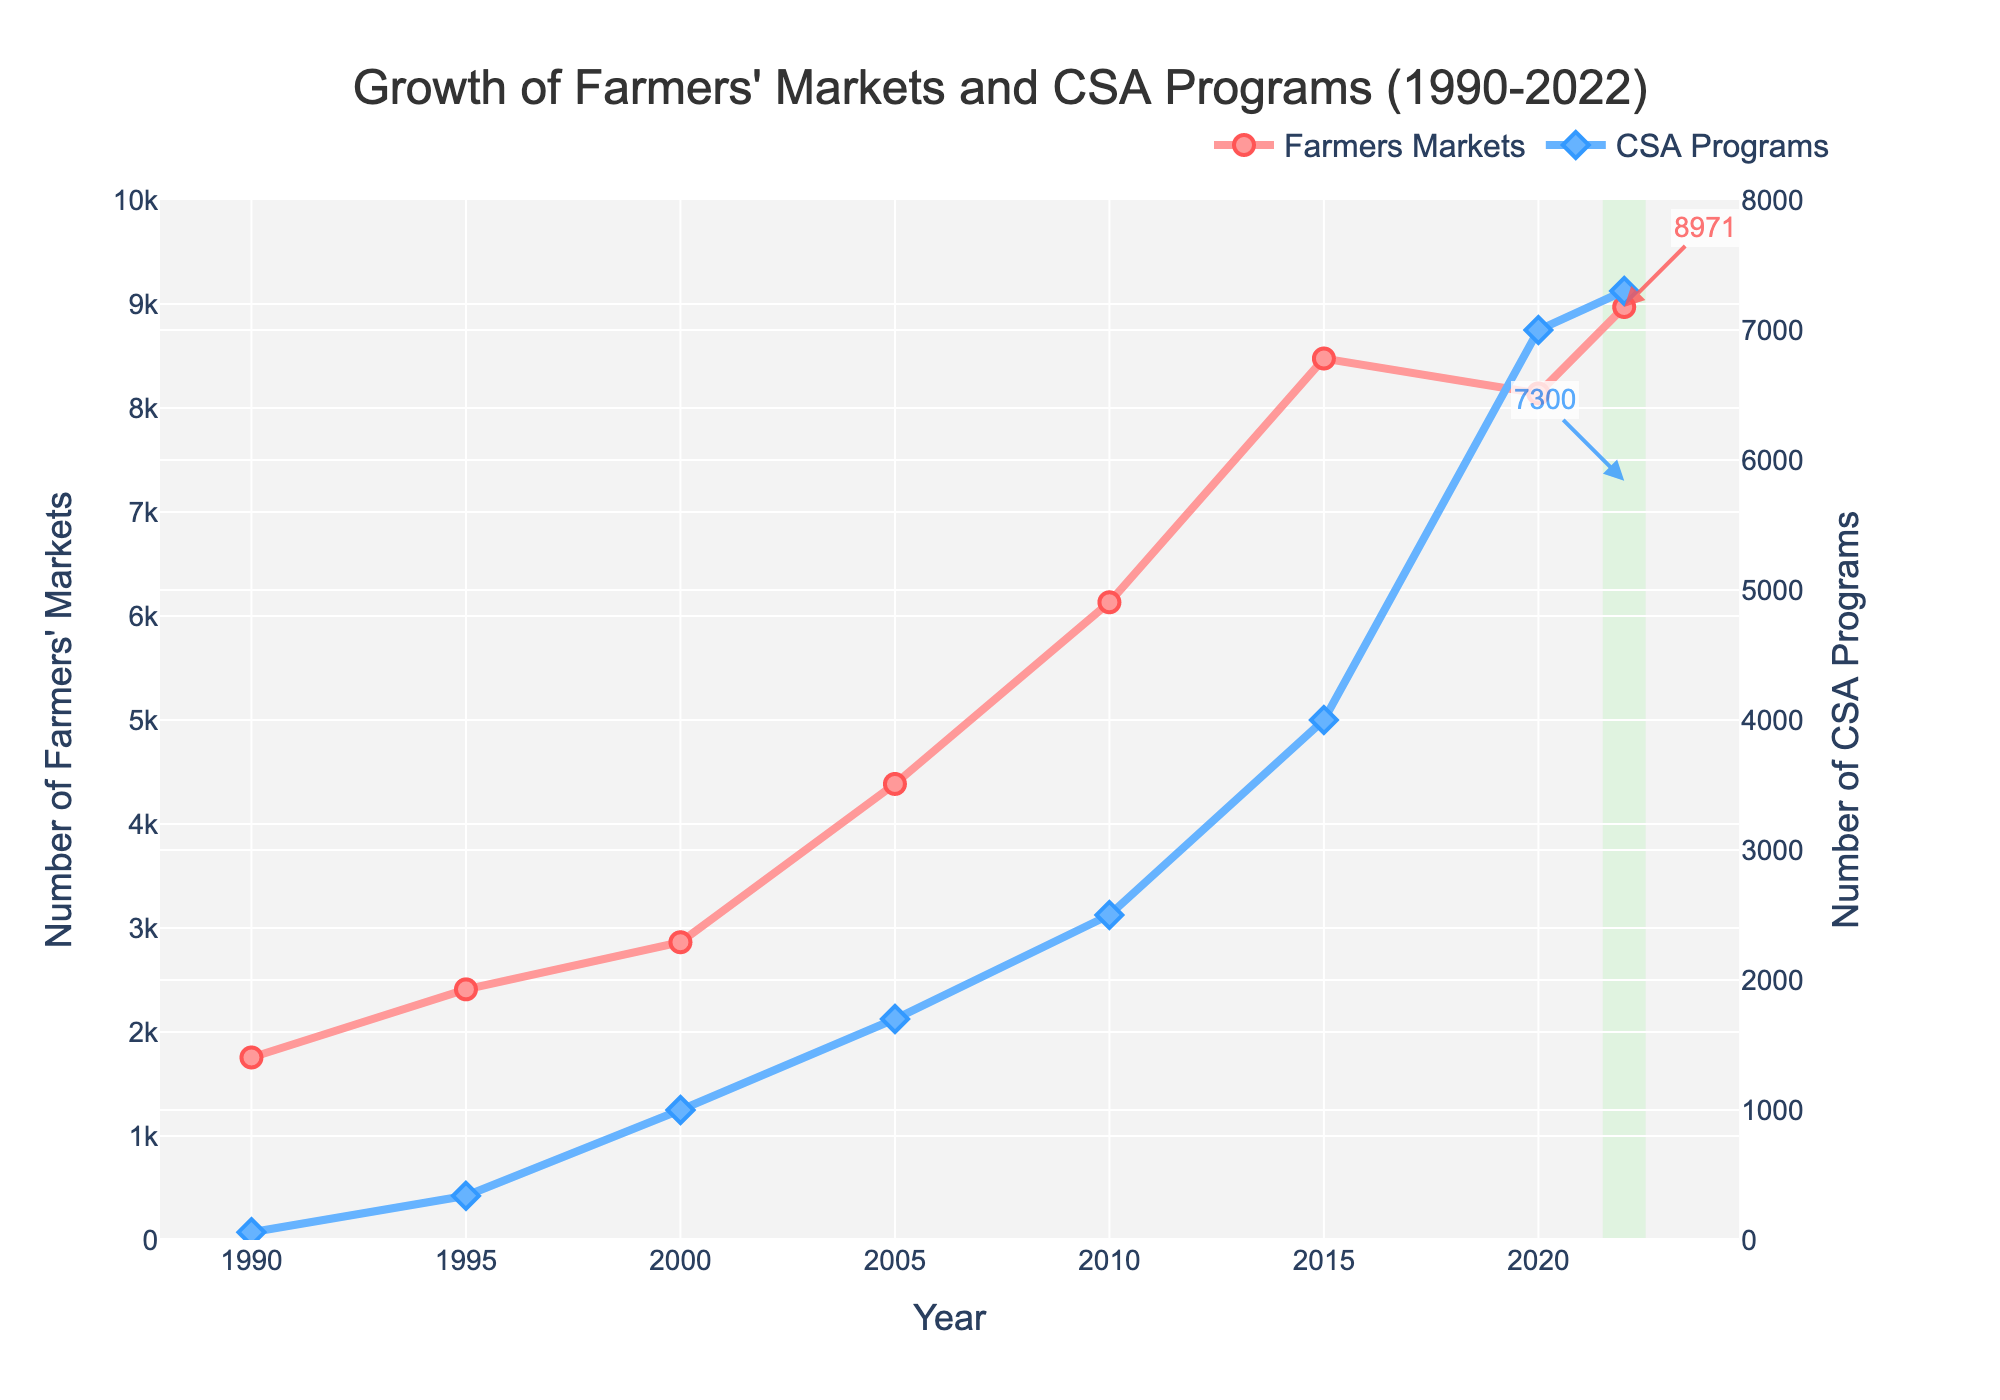What's the increase in the number of farmers' markets from 1990 to 2022? First, find the number of farmers' markets in 1990 (1755) and in 2022 (8971). Then, subtract the 1990 value from the 2022 value: 8971 - 1755 = 7216.
Answer: 7216 Which year saw the highest number of CSA programs? Look at the CSA Programs line and identify the year with the peak value. The highest point on the line for CSA programs is in 2022, where it reaches 7300.
Answer: 2022 In which period did farmers' markets see the largest increase? Observe the Farmers Markets line. The steepest segment appears between 2005 (4385) and 2015 (8476). Calculate the increase: 8476 - 4385 = 4091.
Answer: 2005-2015 Compare the growth trends of farmers' markets and CSA programs from 1990-2022. Look at the two lines for farmers' markets and CSA programs. Farmers' markets grow more consistently, reaching high peaks quicker, while CSA programs have a slower start but show rapid growth after 2000, ending up closer to the farmers' markets count by 2022.
Answer: Farmers' markets show more consistent growth, while CSAs have rapid growth after 2000 What is the average number of farmers' markets in the years provided? Total the number of farmers’ markets for all the years and divide by the number of years: (1755 + 2410 + 2863 + 4385 + 6132 + 8476 + 8140 + 8971) / 8 = 5391.5.
Answer: 5391.5 How did the number of CSA programs change from 2000 to 2020? Determine the values for CSA programs in 2000 (1000) and 2020 (7000). Then, calculate the change: 7000 - 1000 = 6000.
Answer: Increase by 6000 Which had a higher count in 2010, farmers' markets or CSA programs? Compare the values for both in 2010: Farmers' markets had 6132, and CSA programs had 2500. Farmers' markets had a higher count.
Answer: Farmers' markets How many more CSA programs were there in 2022 compared to 1995? Identify the number of CSA programs in 1995 (340) and 2022 (7300). Then calculate the difference: 7300 - 340 = 6960.
Answer: 6960 What is the average yearly growth rate of farmers' markets between 1990 and 2022? First, find the total growth: 8971 (2022) - 1755 (1990) = 7216. Then, divide by the number of years: 7216 / (2022 - 1990) = 7216 / 32 = 225.5 per year.
Answer: 225.5 per year Which has grown more proportionally since 1990: farmers' markets or CSA programs? Calculate the proportional growth by dividing the final number by the initial number for each. Farmers' markets: 8971 / 1755 ≈ 5.11, CSA programs: 7300 / 60 ≈ 121.67, making CSA programs show higher proportional growth.
Answer: CSA programs 